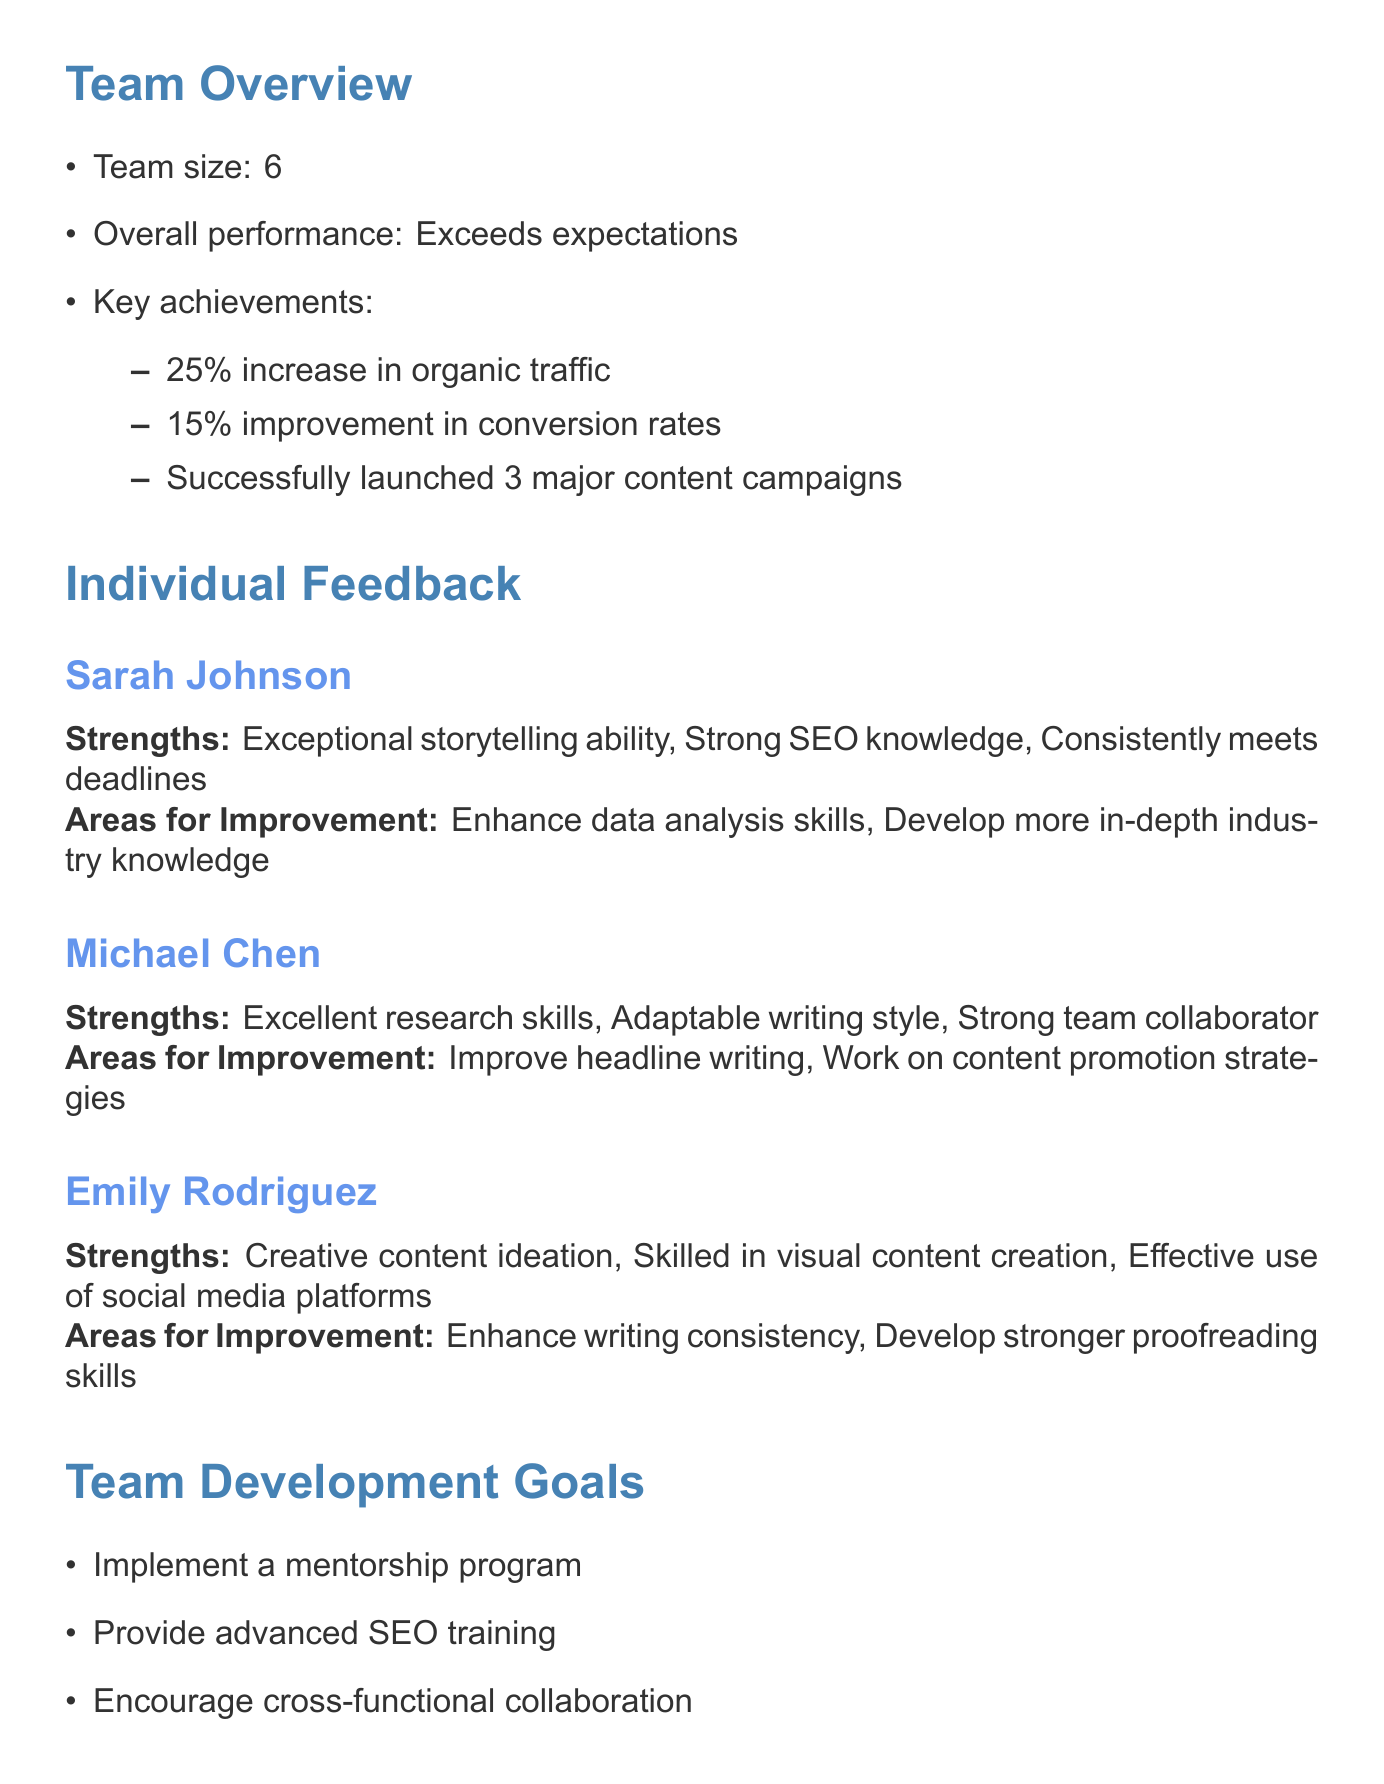What is the team size? The team size is explicitly mentioned in the document under Team Overview.
Answer: 6 What is the overall performance rating of the team? The overall performance is described in the Team Overview section.
Answer: Exceeds expectations How much did organic traffic increase? The percentage increase in organic traffic is listed in the key achievements.
Answer: 25% What are Sarah Johnson's strengths? The strengths for Sarah Johnson are detailed in the individual feedback section.
Answer: Exceptional storytelling ability, Strong SEO knowledge, Consistently meets deadlines What does Michael Chen need to improve? The areas for improvement for Michael Chen are specified in the individual feedback section.
Answer: Improve headline writing, Work on content promotion strategies What type of program is suggested for team development? The specific goals for team development include programs as outlined in the document.
Answer: Implement a mentorship program How many major content campaigns were launched? The number of major content campaigns is included in the key achievements of the team.
Answer: 3 What is one of the upcoming opportunities listed? The document lists several upcoming opportunities that the team can take advantage of.
Answer: Content strategy workshop What skill does Emily Rodriguez need to develop? The area for improvement for Emily Rodriguez is mentioned in her individual feedback.
Answer: Develop stronger proofreading skills 